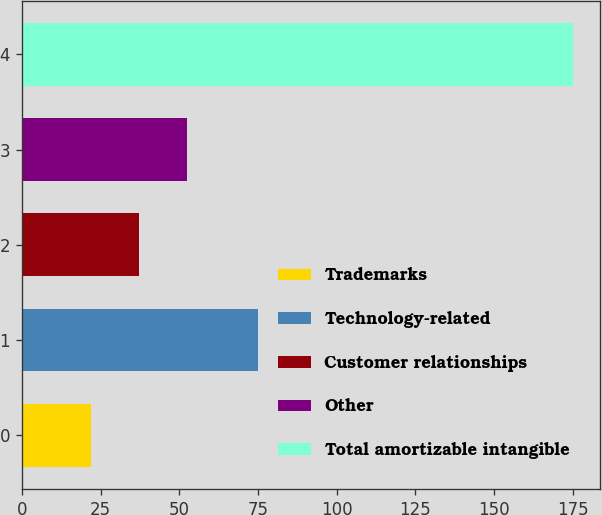Convert chart. <chart><loc_0><loc_0><loc_500><loc_500><bar_chart><fcel>Trademarks<fcel>Technology-related<fcel>Customer relationships<fcel>Other<fcel>Total amortizable intangible<nl><fcel>22<fcel>75<fcel>37.3<fcel>52.6<fcel>175<nl></chart> 